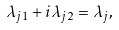Convert formula to latex. <formula><loc_0><loc_0><loc_500><loc_500>\lambda _ { j 1 } + i \lambda _ { j 2 } = \lambda _ { j } ,</formula> 